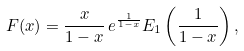Convert formula to latex. <formula><loc_0><loc_0><loc_500><loc_500>F ( x ) = \frac { x } { 1 - x } \, e ^ { \frac { 1 } { 1 - x } } E _ { 1 } \left ( \frac { 1 } { 1 - x } \right ) ,</formula> 